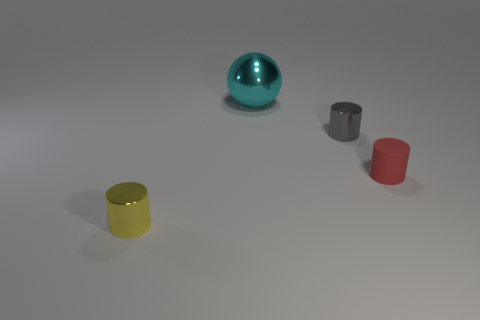Is there another gray matte cylinder of the same size as the rubber cylinder?
Ensure brevity in your answer.  No. Is the yellow cylinder made of the same material as the big sphere?
Offer a terse response. Yes. What number of things are red rubber cylinders or cyan spheres?
Your answer should be compact. 2. What is the size of the cyan ball?
Your answer should be compact. Large. Are there fewer large spheres than things?
Keep it short and to the point. Yes. Does the small metallic cylinder that is to the left of the tiny gray cylinder have the same color as the rubber cylinder?
Keep it short and to the point. No. What is the shape of the red object to the right of the yellow object?
Your answer should be very brief. Cylinder. Is there a red matte cylinder that is in front of the metal thing that is on the left side of the sphere?
Give a very brief answer. No. What number of large cyan objects have the same material as the red cylinder?
Your answer should be compact. 0. There is a shiny cylinder behind the tiny metal cylinder in front of the small metal thing right of the small yellow metal cylinder; what size is it?
Your answer should be very brief. Small. 